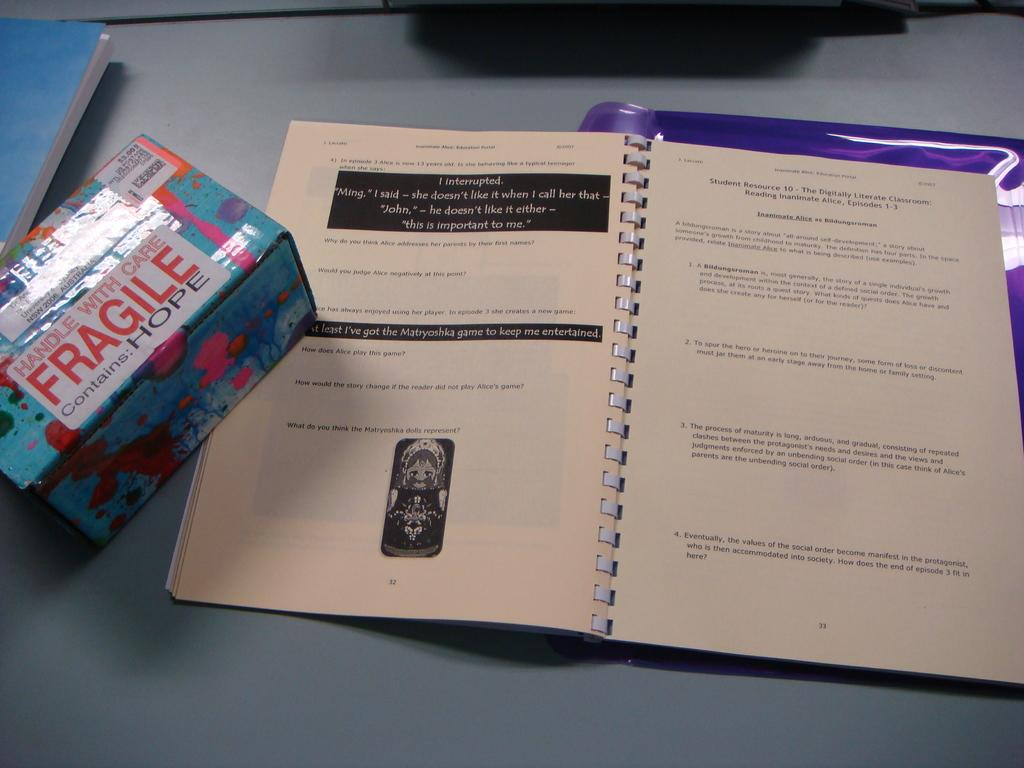<image>
Provide a brief description of the given image. A box has a sticker on it that says "Fragile, contains Hope". 